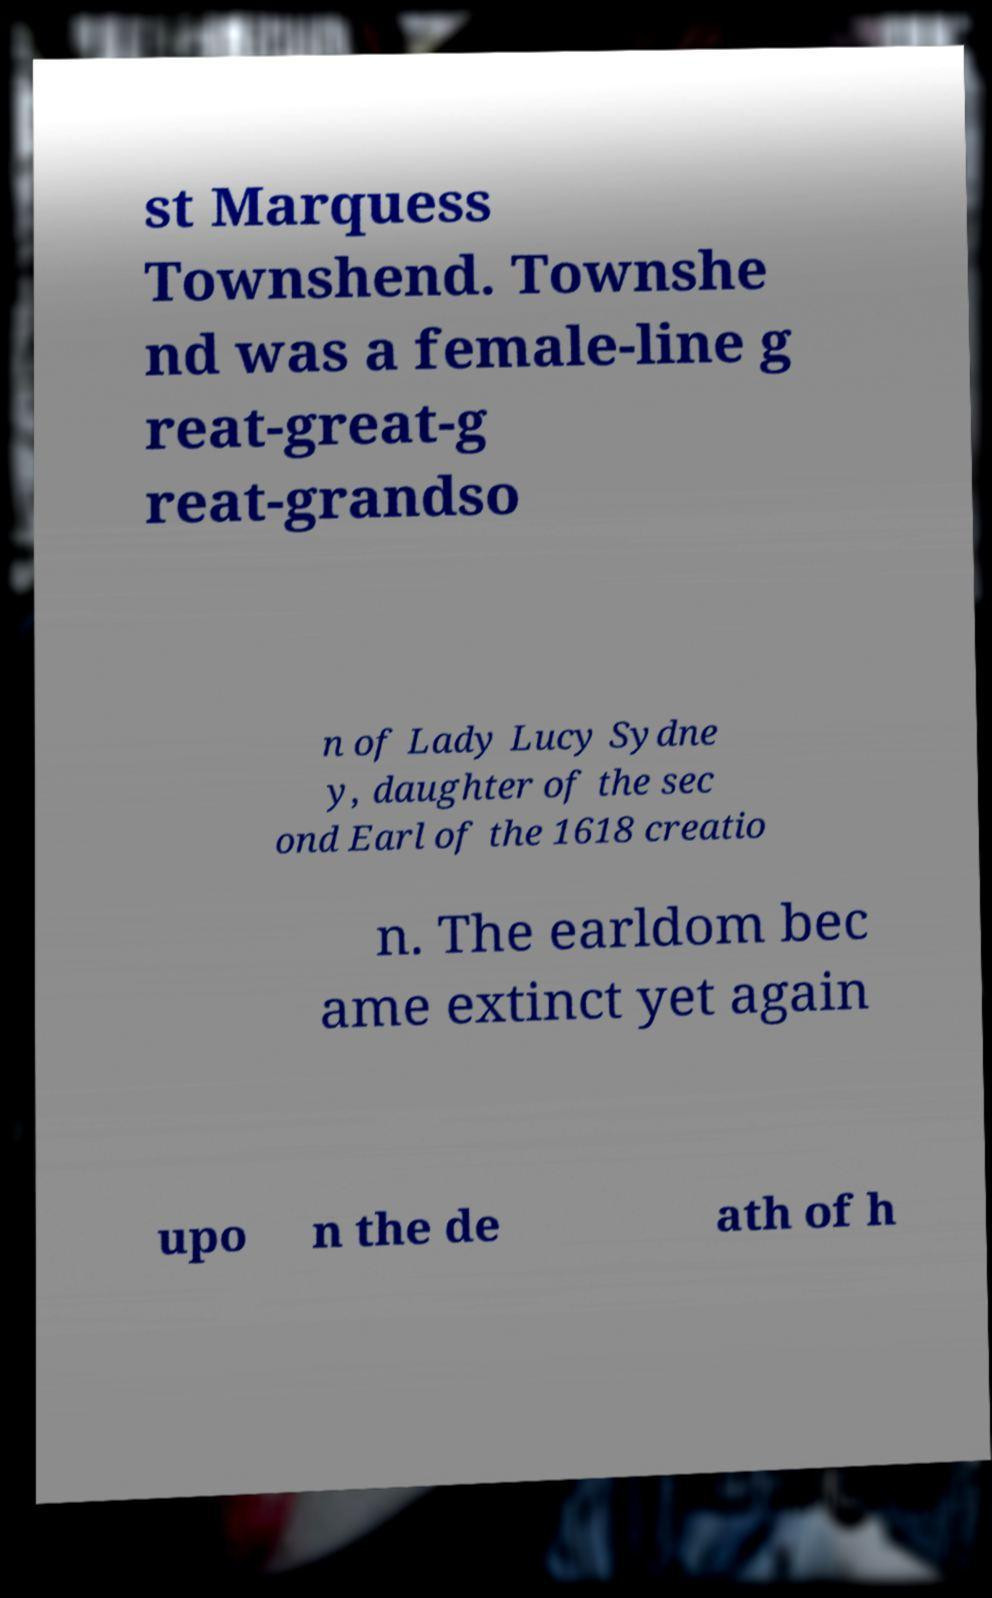What messages or text are displayed in this image? I need them in a readable, typed format. st Marquess Townshend. Townshe nd was a female-line g reat-great-g reat-grandso n of Lady Lucy Sydne y, daughter of the sec ond Earl of the 1618 creatio n. The earldom bec ame extinct yet again upo n the de ath of h 